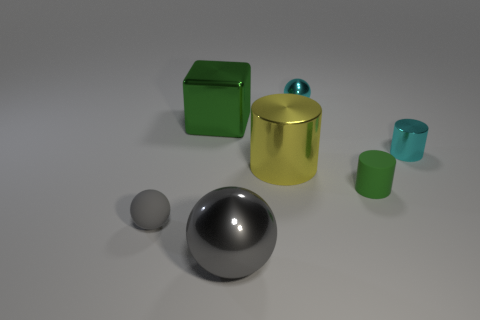What number of objects are behind the tiny green object and on the left side of the large cylinder?
Offer a very short reply. 1. What number of rubber objects are large green things or big gray things?
Give a very brief answer. 0. What material is the big thing behind the small shiny object that is on the right side of the small green object?
Provide a short and direct response. Metal. There is a thing that is the same color as the large metal ball; what shape is it?
Provide a succinct answer. Sphere. What shape is the gray metallic object that is the same size as the green block?
Provide a short and direct response. Sphere. Is the number of small cyan metal things less than the number of large shiny cubes?
Your answer should be compact. No. There is a thing to the left of the large metal cube; are there any gray rubber balls that are on the right side of it?
Your response must be concise. No. There is a tiny green thing that is the same material as the tiny gray thing; what shape is it?
Provide a succinct answer. Cylinder. Is there anything else of the same color as the matte cylinder?
Offer a very short reply. Yes. There is a cyan object that is the same shape as the yellow object; what is it made of?
Offer a terse response. Metal. 